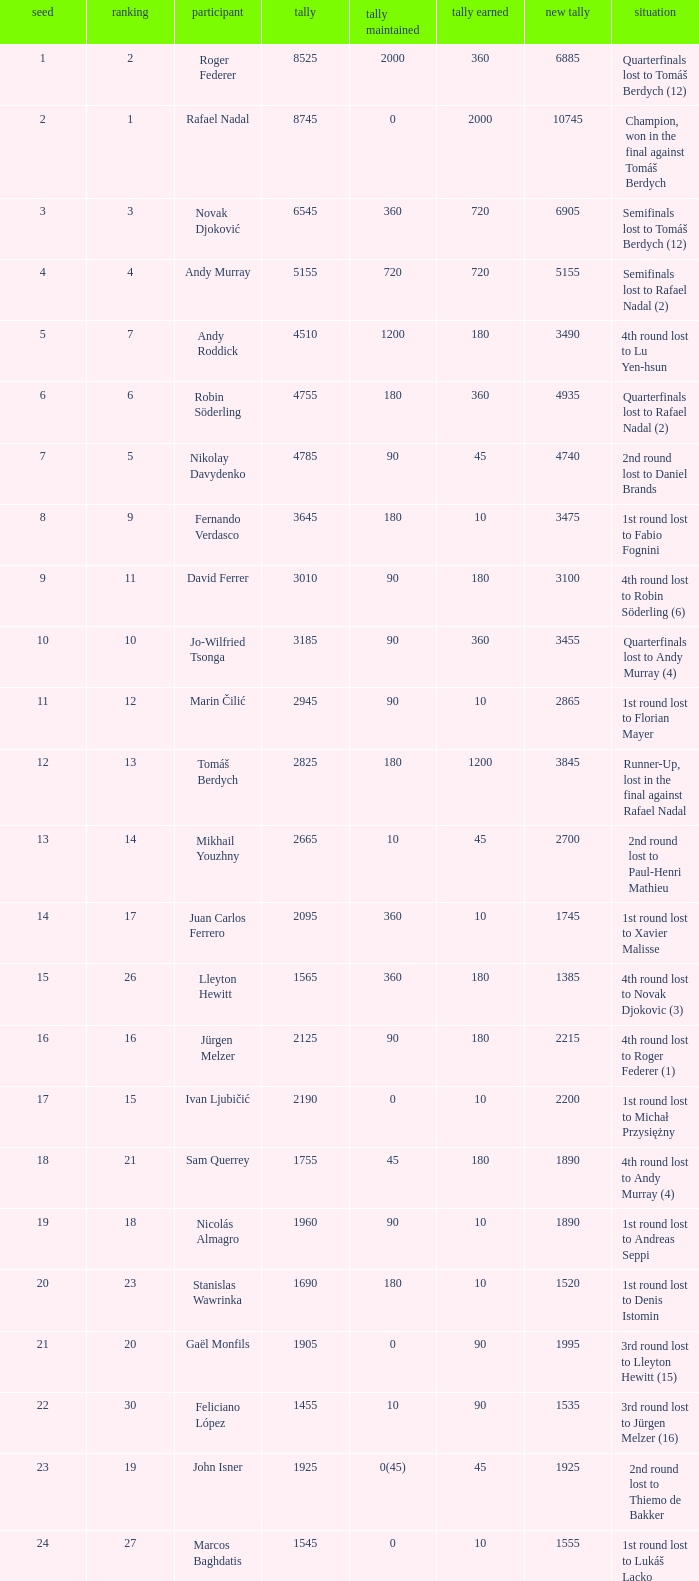Name the status for points 3185 Quarterfinals lost to Andy Murray (4). 